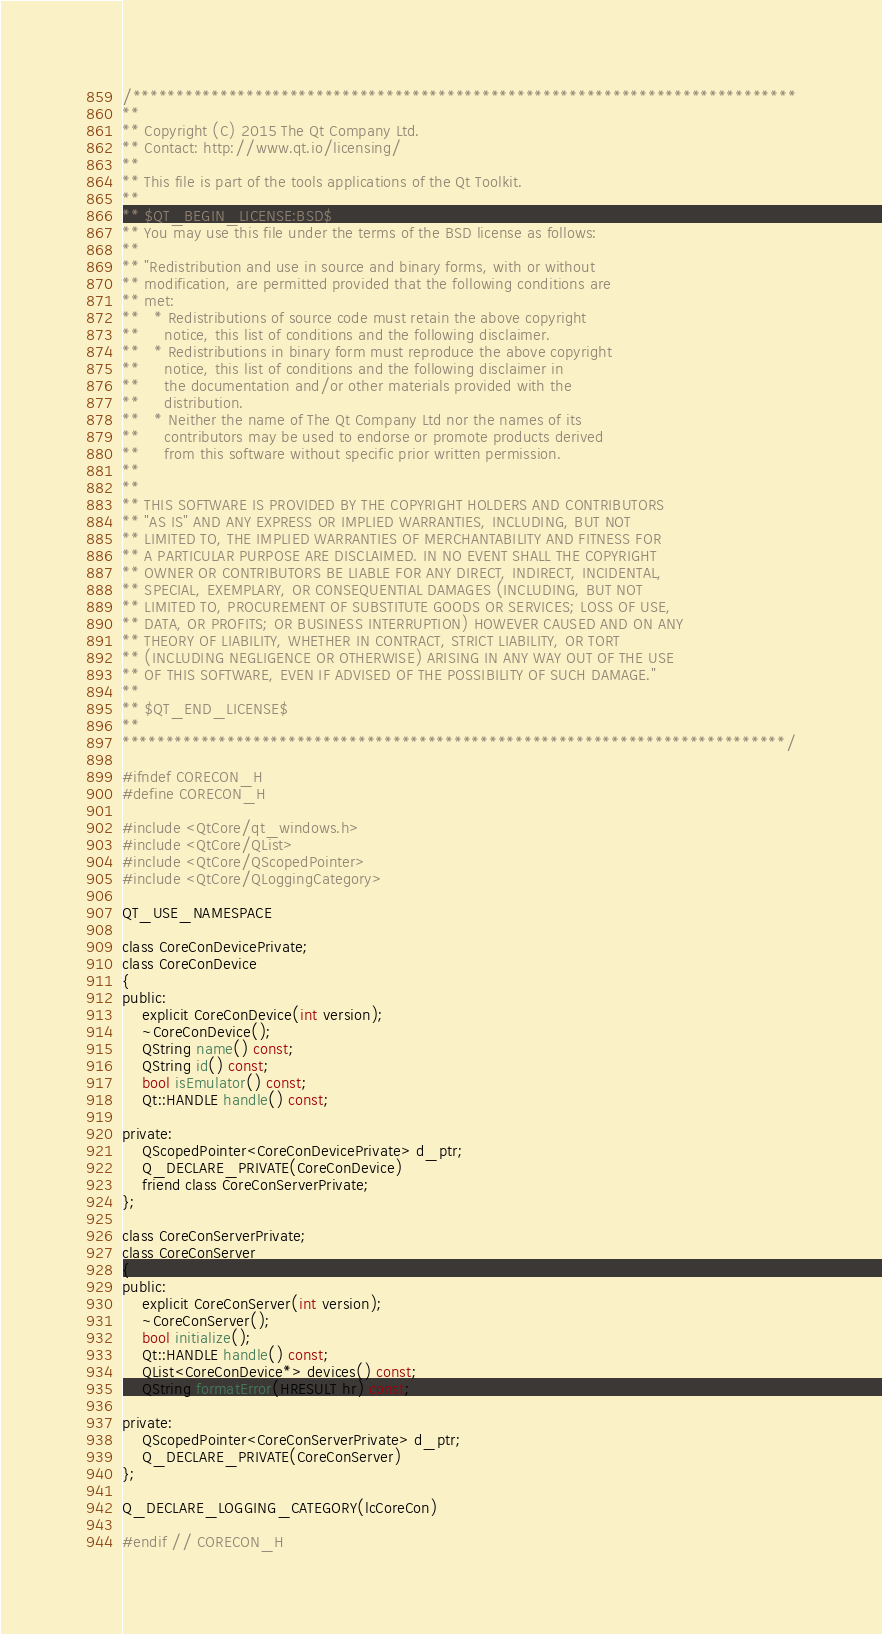<code> <loc_0><loc_0><loc_500><loc_500><_C_>/****************************************************************************
**
** Copyright (C) 2015 The Qt Company Ltd.
** Contact: http://www.qt.io/licensing/
**
** This file is part of the tools applications of the Qt Toolkit.
**
** $QT_BEGIN_LICENSE:BSD$
** You may use this file under the terms of the BSD license as follows:
**
** "Redistribution and use in source and binary forms, with or without
** modification, are permitted provided that the following conditions are
** met:
**   * Redistributions of source code must retain the above copyright
**     notice, this list of conditions and the following disclaimer.
**   * Redistributions in binary form must reproduce the above copyright
**     notice, this list of conditions and the following disclaimer in
**     the documentation and/or other materials provided with the
**     distribution.
**   * Neither the name of The Qt Company Ltd nor the names of its
**     contributors may be used to endorse or promote products derived
**     from this software without specific prior written permission.
**
**
** THIS SOFTWARE IS PROVIDED BY THE COPYRIGHT HOLDERS AND CONTRIBUTORS
** "AS IS" AND ANY EXPRESS OR IMPLIED WARRANTIES, INCLUDING, BUT NOT
** LIMITED TO, THE IMPLIED WARRANTIES OF MERCHANTABILITY AND FITNESS FOR
** A PARTICULAR PURPOSE ARE DISCLAIMED. IN NO EVENT SHALL THE COPYRIGHT
** OWNER OR CONTRIBUTORS BE LIABLE FOR ANY DIRECT, INDIRECT, INCIDENTAL,
** SPECIAL, EXEMPLARY, OR CONSEQUENTIAL DAMAGES (INCLUDING, BUT NOT
** LIMITED TO, PROCUREMENT OF SUBSTITUTE GOODS OR SERVICES; LOSS OF USE,
** DATA, OR PROFITS; OR BUSINESS INTERRUPTION) HOWEVER CAUSED AND ON ANY
** THEORY OF LIABILITY, WHETHER IN CONTRACT, STRICT LIABILITY, OR TORT
** (INCLUDING NEGLIGENCE OR OTHERWISE) ARISING IN ANY WAY OUT OF THE USE
** OF THIS SOFTWARE, EVEN IF ADVISED OF THE POSSIBILITY OF SUCH DAMAGE."
**
** $QT_END_LICENSE$
**
****************************************************************************/

#ifndef CORECON_H
#define CORECON_H

#include <QtCore/qt_windows.h>
#include <QtCore/QList>
#include <QtCore/QScopedPointer>
#include <QtCore/QLoggingCategory>

QT_USE_NAMESPACE

class CoreConDevicePrivate;
class CoreConDevice
{
public:
    explicit CoreConDevice(int version);
    ~CoreConDevice();
    QString name() const;
    QString id() const;
    bool isEmulator() const;
    Qt::HANDLE handle() const;

private:
    QScopedPointer<CoreConDevicePrivate> d_ptr;
    Q_DECLARE_PRIVATE(CoreConDevice)
    friend class CoreConServerPrivate;
};

class CoreConServerPrivate;
class CoreConServer
{
public:
    explicit CoreConServer(int version);
    ~CoreConServer();
    bool initialize();
    Qt::HANDLE handle() const;
    QList<CoreConDevice*> devices() const;
    QString formatError(HRESULT hr) const;

private:
    QScopedPointer<CoreConServerPrivate> d_ptr;
    Q_DECLARE_PRIVATE(CoreConServer)
};

Q_DECLARE_LOGGING_CATEGORY(lcCoreCon)

#endif // CORECON_H
</code> 